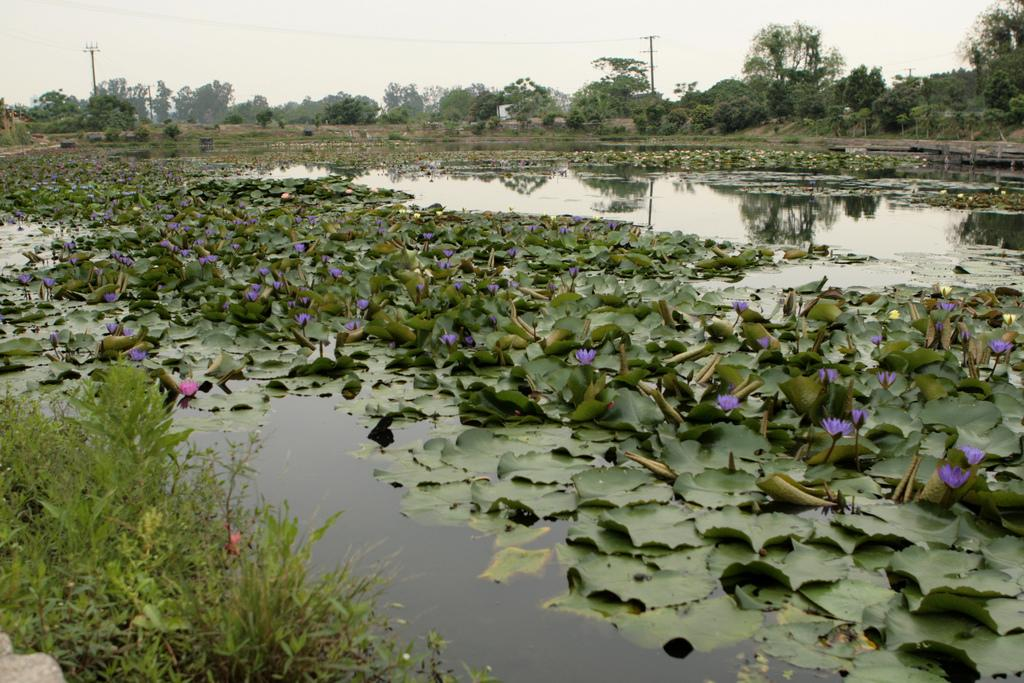What type of plants can be seen in the water in the image? There are aquatic plants in the water in the image. How are the aquatic plants positioned in the water? The aquatic plants are floating in the water. What type of vegetation surrounds the area in the image? The area is surrounded by trees and bushes. What month is it in the image? The image does not provide any information about the month or time of year. What type of cable can be seen in the image? There is no cable present in the image. 